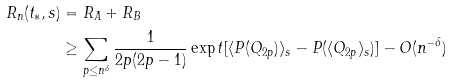<formula> <loc_0><loc_0><loc_500><loc_500>R _ { n } ( t _ { * } , s ) & = R _ { A } + R _ { B } \\ & \geq \sum _ { p \leq n ^ { \delta } } \frac { 1 } { 2 p ( 2 p - 1 ) } \exp t [ \langle P ( Q _ { 2 p } ) \rangle _ { s } - P ( \langle Q _ { 2 p } \rangle _ { s } ) ] - O ( n ^ { - \delta } )</formula> 